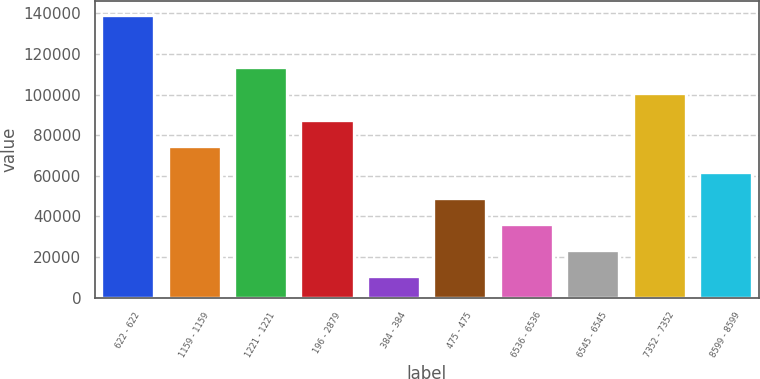<chart> <loc_0><loc_0><loc_500><loc_500><bar_chart><fcel>622 - 622<fcel>1159 - 1159<fcel>1221 - 1221<fcel>196 - 2879<fcel>384 - 384<fcel>475 - 475<fcel>6536 - 6536<fcel>6545 - 6545<fcel>7352 - 7352<fcel>8599 - 8599<nl><fcel>139250<fcel>74805<fcel>113472<fcel>87694<fcel>10360<fcel>49027<fcel>36138<fcel>23249<fcel>100583<fcel>61916<nl></chart> 